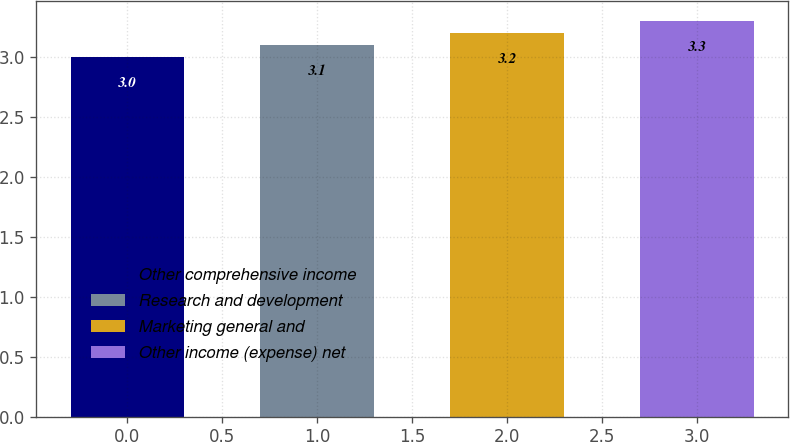Convert chart. <chart><loc_0><loc_0><loc_500><loc_500><bar_chart><fcel>Other comprehensive income<fcel>Research and development<fcel>Marketing general and<fcel>Other income (expense) net<nl><fcel>3<fcel>3.1<fcel>3.2<fcel>3.3<nl></chart> 